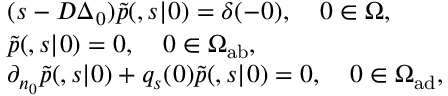Convert formula to latex. <formula><loc_0><loc_0><loc_500><loc_500>\begin{array} { r l } & { ( s - D \Delta _ { \ r _ { 0 } } ) \tilde { p } ( \ r , s | \ r _ { 0 } ) = \delta ( \ r - \ r _ { 0 } ) , \quad \ r _ { 0 } \in \Omega , } \\ & { \tilde { p } ( \ r , s | \ r _ { 0 } ) = 0 , \quad \ r _ { 0 } \in \Omega _ { a b } , } \\ & { \partial _ { n _ { 0 } } \tilde { p } ( \ r , s | \ r _ { 0 } ) + q _ { s } ( \ r _ { 0 } ) \tilde { p } ( \ r , s | \ r _ { 0 } ) = 0 , \quad \ r _ { 0 } \in \Omega _ { a d } , } \end{array}</formula> 